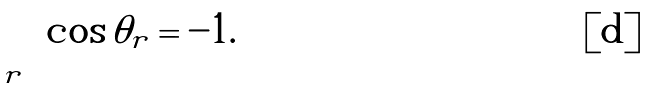Convert formula to latex. <formula><loc_0><loc_0><loc_500><loc_500>\sum _ { r } \cos \theta _ { r } = - 1 .</formula> 